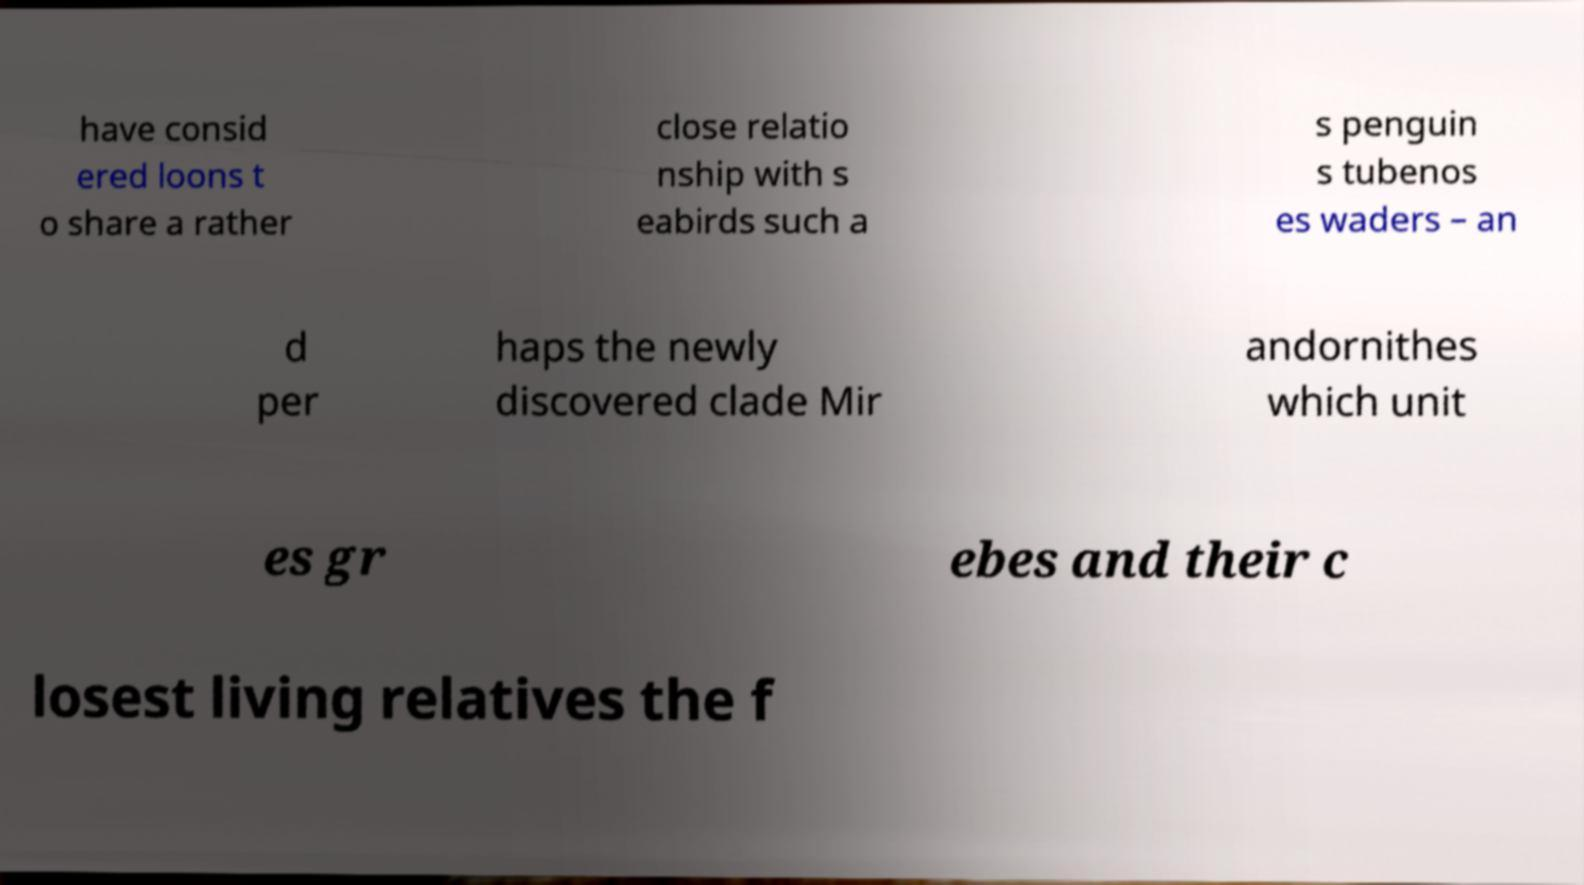Could you extract and type out the text from this image? have consid ered loons t o share a rather close relatio nship with s eabirds such a s penguin s tubenos es waders – an d per haps the newly discovered clade Mir andornithes which unit es gr ebes and their c losest living relatives the f 